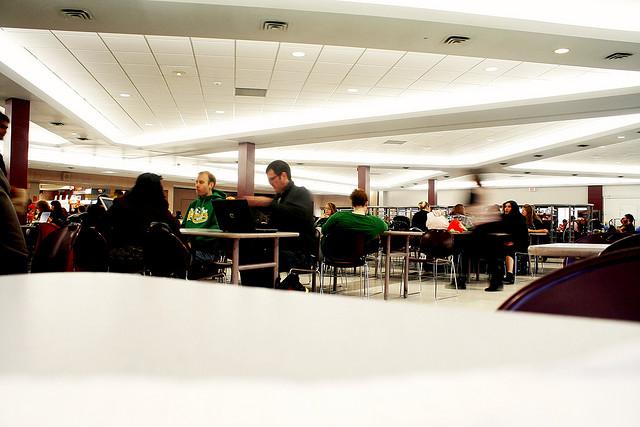Do you see a laptop?
Short answer required. Yes. How many people are sitting at the table to the left?
Concise answer only. 3. How many people are sitting at tables in this room?
Concise answer only. Many. 